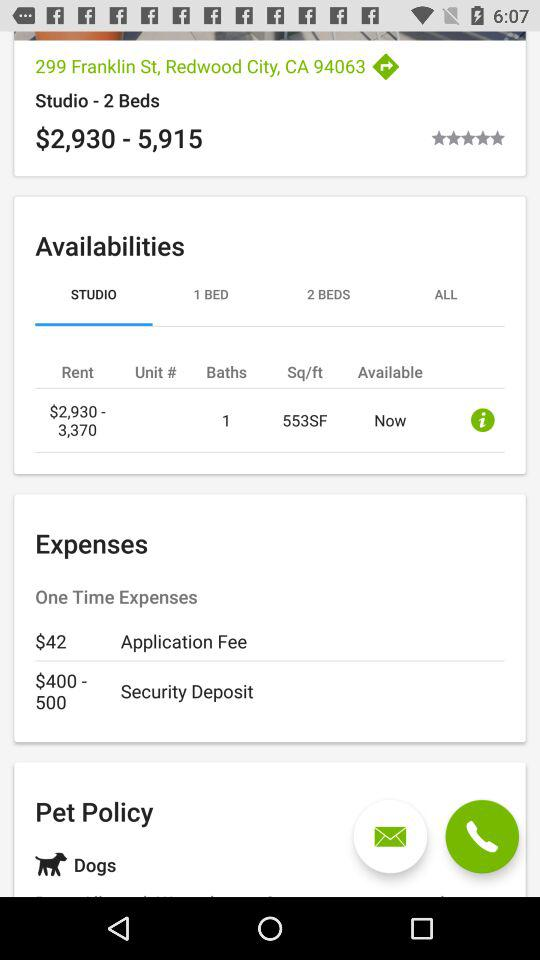How many square feet are there? There are 553 square feet. 